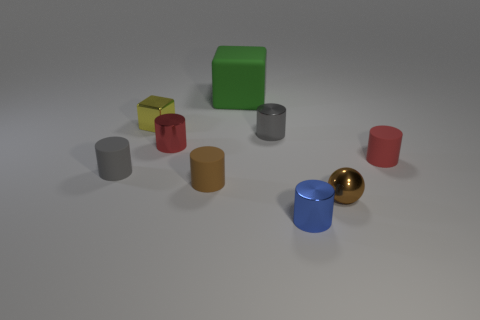Subtract all red cylinders. How many were subtracted if there are1red cylinders left? 1 Subtract all gray metal cylinders. How many cylinders are left? 5 Subtract 1 blue cylinders. How many objects are left? 8 Subtract all spheres. How many objects are left? 8 Subtract 1 balls. How many balls are left? 0 Subtract all green cylinders. Subtract all gray spheres. How many cylinders are left? 6 Subtract all yellow cylinders. How many yellow blocks are left? 1 Subtract all big purple matte things. Subtract all blue cylinders. How many objects are left? 8 Add 2 green cubes. How many green cubes are left? 3 Add 9 big gray objects. How many big gray objects exist? 9 